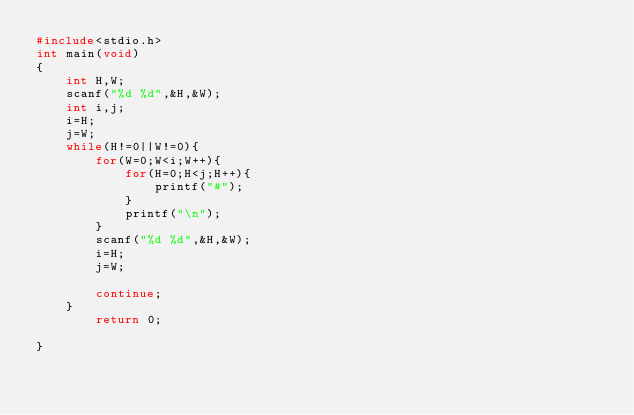<code> <loc_0><loc_0><loc_500><loc_500><_C_>#include<stdio.h>
int main(void)
{
    int H,W;
    scanf("%d %d",&H,&W);
    int i,j;
    i=H;
    j=W;
    while(H!=0||W!=0){
        for(W=0;W<i;W++){
            for(H=0;H<j;H++){
                printf("#");
            }
            printf("\n");
        }
        scanf("%d %d",&H,&W);
        i=H;
        j=W;

        continue;
    }
        return 0;

}</code> 